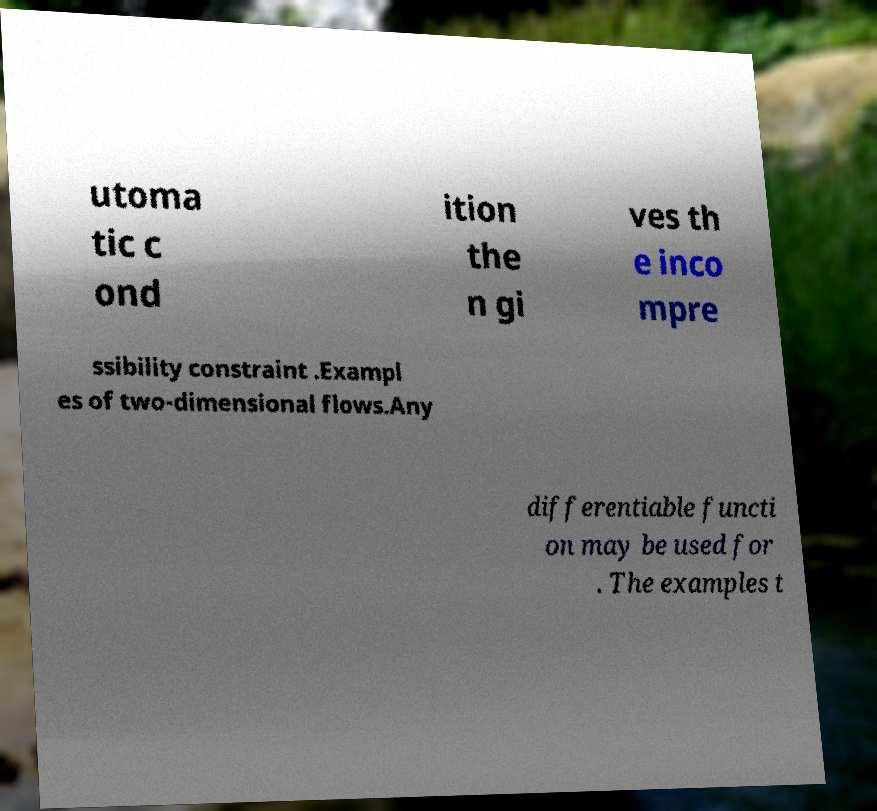For documentation purposes, I need the text within this image transcribed. Could you provide that? utoma tic c ond ition the n gi ves th e inco mpre ssibility constraint .Exampl es of two-dimensional flows.Any differentiable functi on may be used for . The examples t 